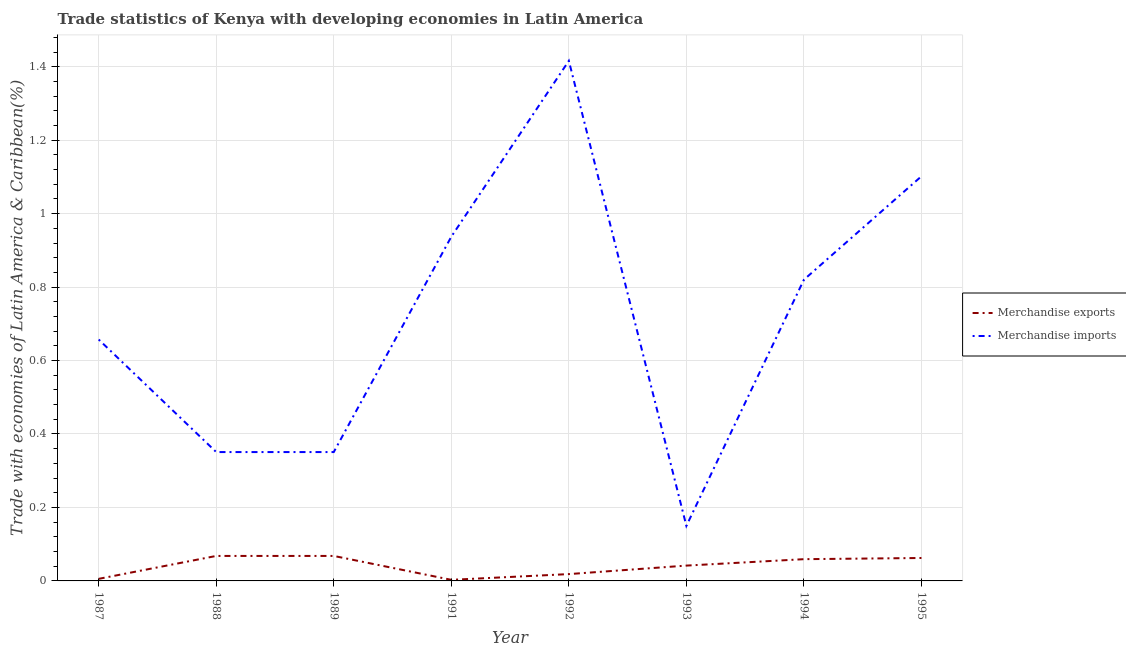How many different coloured lines are there?
Offer a very short reply. 2. Does the line corresponding to merchandise imports intersect with the line corresponding to merchandise exports?
Keep it short and to the point. No. Is the number of lines equal to the number of legend labels?
Provide a short and direct response. Yes. What is the merchandise imports in 1987?
Provide a succinct answer. 0.66. Across all years, what is the maximum merchandise exports?
Ensure brevity in your answer.  0.07. Across all years, what is the minimum merchandise imports?
Give a very brief answer. 0.15. In which year was the merchandise exports minimum?
Ensure brevity in your answer.  1991. What is the total merchandise exports in the graph?
Offer a terse response. 0.33. What is the difference between the merchandise imports in 1991 and that in 1992?
Your answer should be compact. -0.48. What is the difference between the merchandise exports in 1989 and the merchandise imports in 1995?
Your response must be concise. -1.03. What is the average merchandise imports per year?
Your answer should be compact. 0.72. In the year 1994, what is the difference between the merchandise imports and merchandise exports?
Your answer should be compact. 0.76. What is the ratio of the merchandise imports in 1987 to that in 1995?
Provide a short and direct response. 0.6. Is the merchandise exports in 1992 less than that in 1994?
Provide a short and direct response. Yes. What is the difference between the highest and the second highest merchandise imports?
Ensure brevity in your answer.  0.31. What is the difference between the highest and the lowest merchandise imports?
Provide a succinct answer. 1.27. What is the difference between two consecutive major ticks on the Y-axis?
Offer a terse response. 0.2. How are the legend labels stacked?
Provide a succinct answer. Vertical. What is the title of the graph?
Give a very brief answer. Trade statistics of Kenya with developing economies in Latin America. Does "Primary school" appear as one of the legend labels in the graph?
Offer a very short reply. No. What is the label or title of the X-axis?
Offer a very short reply. Year. What is the label or title of the Y-axis?
Your answer should be very brief. Trade with economies of Latin America & Caribbean(%). What is the Trade with economies of Latin America & Caribbean(%) in Merchandise exports in 1987?
Your answer should be compact. 0.01. What is the Trade with economies of Latin America & Caribbean(%) of Merchandise imports in 1987?
Keep it short and to the point. 0.66. What is the Trade with economies of Latin America & Caribbean(%) in Merchandise exports in 1988?
Offer a terse response. 0.07. What is the Trade with economies of Latin America & Caribbean(%) of Merchandise imports in 1988?
Keep it short and to the point. 0.35. What is the Trade with economies of Latin America & Caribbean(%) of Merchandise exports in 1989?
Provide a short and direct response. 0.07. What is the Trade with economies of Latin America & Caribbean(%) of Merchandise imports in 1989?
Provide a short and direct response. 0.35. What is the Trade with economies of Latin America & Caribbean(%) in Merchandise exports in 1991?
Offer a terse response. 0. What is the Trade with economies of Latin America & Caribbean(%) in Merchandise imports in 1991?
Your response must be concise. 0.94. What is the Trade with economies of Latin America & Caribbean(%) in Merchandise exports in 1992?
Offer a very short reply. 0.02. What is the Trade with economies of Latin America & Caribbean(%) in Merchandise imports in 1992?
Offer a very short reply. 1.42. What is the Trade with economies of Latin America & Caribbean(%) of Merchandise exports in 1993?
Your answer should be very brief. 0.04. What is the Trade with economies of Latin America & Caribbean(%) of Merchandise imports in 1993?
Provide a short and direct response. 0.15. What is the Trade with economies of Latin America & Caribbean(%) of Merchandise exports in 1994?
Make the answer very short. 0.06. What is the Trade with economies of Latin America & Caribbean(%) in Merchandise imports in 1994?
Offer a terse response. 0.82. What is the Trade with economies of Latin America & Caribbean(%) of Merchandise exports in 1995?
Keep it short and to the point. 0.06. What is the Trade with economies of Latin America & Caribbean(%) in Merchandise imports in 1995?
Provide a succinct answer. 1.1. Across all years, what is the maximum Trade with economies of Latin America & Caribbean(%) in Merchandise exports?
Offer a terse response. 0.07. Across all years, what is the maximum Trade with economies of Latin America & Caribbean(%) in Merchandise imports?
Your answer should be very brief. 1.42. Across all years, what is the minimum Trade with economies of Latin America & Caribbean(%) of Merchandise exports?
Your answer should be very brief. 0. Across all years, what is the minimum Trade with economies of Latin America & Caribbean(%) in Merchandise imports?
Ensure brevity in your answer.  0.15. What is the total Trade with economies of Latin America & Caribbean(%) of Merchandise exports in the graph?
Provide a short and direct response. 0.33. What is the total Trade with economies of Latin America & Caribbean(%) of Merchandise imports in the graph?
Offer a terse response. 5.78. What is the difference between the Trade with economies of Latin America & Caribbean(%) of Merchandise exports in 1987 and that in 1988?
Your response must be concise. -0.06. What is the difference between the Trade with economies of Latin America & Caribbean(%) of Merchandise imports in 1987 and that in 1988?
Make the answer very short. 0.31. What is the difference between the Trade with economies of Latin America & Caribbean(%) in Merchandise exports in 1987 and that in 1989?
Offer a very short reply. -0.06. What is the difference between the Trade with economies of Latin America & Caribbean(%) in Merchandise imports in 1987 and that in 1989?
Ensure brevity in your answer.  0.31. What is the difference between the Trade with economies of Latin America & Caribbean(%) in Merchandise exports in 1987 and that in 1991?
Ensure brevity in your answer.  0. What is the difference between the Trade with economies of Latin America & Caribbean(%) of Merchandise imports in 1987 and that in 1991?
Offer a terse response. -0.28. What is the difference between the Trade with economies of Latin America & Caribbean(%) in Merchandise exports in 1987 and that in 1992?
Provide a short and direct response. -0.01. What is the difference between the Trade with economies of Latin America & Caribbean(%) in Merchandise imports in 1987 and that in 1992?
Offer a very short reply. -0.76. What is the difference between the Trade with economies of Latin America & Caribbean(%) of Merchandise exports in 1987 and that in 1993?
Your answer should be compact. -0.04. What is the difference between the Trade with economies of Latin America & Caribbean(%) of Merchandise imports in 1987 and that in 1993?
Offer a very short reply. 0.51. What is the difference between the Trade with economies of Latin America & Caribbean(%) in Merchandise exports in 1987 and that in 1994?
Offer a very short reply. -0.05. What is the difference between the Trade with economies of Latin America & Caribbean(%) of Merchandise imports in 1987 and that in 1994?
Provide a short and direct response. -0.16. What is the difference between the Trade with economies of Latin America & Caribbean(%) in Merchandise exports in 1987 and that in 1995?
Give a very brief answer. -0.06. What is the difference between the Trade with economies of Latin America & Caribbean(%) in Merchandise imports in 1987 and that in 1995?
Keep it short and to the point. -0.44. What is the difference between the Trade with economies of Latin America & Caribbean(%) of Merchandise imports in 1988 and that in 1989?
Your response must be concise. -0. What is the difference between the Trade with economies of Latin America & Caribbean(%) in Merchandise exports in 1988 and that in 1991?
Provide a short and direct response. 0.07. What is the difference between the Trade with economies of Latin America & Caribbean(%) in Merchandise imports in 1988 and that in 1991?
Offer a very short reply. -0.59. What is the difference between the Trade with economies of Latin America & Caribbean(%) of Merchandise exports in 1988 and that in 1992?
Give a very brief answer. 0.05. What is the difference between the Trade with economies of Latin America & Caribbean(%) of Merchandise imports in 1988 and that in 1992?
Your answer should be compact. -1.07. What is the difference between the Trade with economies of Latin America & Caribbean(%) of Merchandise exports in 1988 and that in 1993?
Give a very brief answer. 0.03. What is the difference between the Trade with economies of Latin America & Caribbean(%) in Merchandise imports in 1988 and that in 1993?
Offer a very short reply. 0.2. What is the difference between the Trade with economies of Latin America & Caribbean(%) of Merchandise exports in 1988 and that in 1994?
Provide a short and direct response. 0.01. What is the difference between the Trade with economies of Latin America & Caribbean(%) of Merchandise imports in 1988 and that in 1994?
Make the answer very short. -0.47. What is the difference between the Trade with economies of Latin America & Caribbean(%) of Merchandise exports in 1988 and that in 1995?
Give a very brief answer. 0.01. What is the difference between the Trade with economies of Latin America & Caribbean(%) in Merchandise imports in 1988 and that in 1995?
Make the answer very short. -0.75. What is the difference between the Trade with economies of Latin America & Caribbean(%) of Merchandise exports in 1989 and that in 1991?
Give a very brief answer. 0.07. What is the difference between the Trade with economies of Latin America & Caribbean(%) in Merchandise imports in 1989 and that in 1991?
Offer a very short reply. -0.59. What is the difference between the Trade with economies of Latin America & Caribbean(%) in Merchandise exports in 1989 and that in 1992?
Offer a terse response. 0.05. What is the difference between the Trade with economies of Latin America & Caribbean(%) of Merchandise imports in 1989 and that in 1992?
Provide a short and direct response. -1.07. What is the difference between the Trade with economies of Latin America & Caribbean(%) in Merchandise exports in 1989 and that in 1993?
Your answer should be compact. 0.03. What is the difference between the Trade with economies of Latin America & Caribbean(%) in Merchandise imports in 1989 and that in 1993?
Give a very brief answer. 0.2. What is the difference between the Trade with economies of Latin America & Caribbean(%) in Merchandise exports in 1989 and that in 1994?
Keep it short and to the point. 0.01. What is the difference between the Trade with economies of Latin America & Caribbean(%) of Merchandise imports in 1989 and that in 1994?
Your answer should be very brief. -0.47. What is the difference between the Trade with economies of Latin America & Caribbean(%) of Merchandise exports in 1989 and that in 1995?
Your answer should be very brief. 0.01. What is the difference between the Trade with economies of Latin America & Caribbean(%) in Merchandise imports in 1989 and that in 1995?
Provide a succinct answer. -0.75. What is the difference between the Trade with economies of Latin America & Caribbean(%) in Merchandise exports in 1991 and that in 1992?
Offer a very short reply. -0.02. What is the difference between the Trade with economies of Latin America & Caribbean(%) of Merchandise imports in 1991 and that in 1992?
Your answer should be compact. -0.48. What is the difference between the Trade with economies of Latin America & Caribbean(%) of Merchandise exports in 1991 and that in 1993?
Offer a terse response. -0.04. What is the difference between the Trade with economies of Latin America & Caribbean(%) in Merchandise imports in 1991 and that in 1993?
Your response must be concise. 0.79. What is the difference between the Trade with economies of Latin America & Caribbean(%) in Merchandise exports in 1991 and that in 1994?
Your answer should be compact. -0.06. What is the difference between the Trade with economies of Latin America & Caribbean(%) of Merchandise imports in 1991 and that in 1994?
Provide a succinct answer. 0.12. What is the difference between the Trade with economies of Latin America & Caribbean(%) of Merchandise exports in 1991 and that in 1995?
Your response must be concise. -0.06. What is the difference between the Trade with economies of Latin America & Caribbean(%) in Merchandise imports in 1991 and that in 1995?
Your response must be concise. -0.16. What is the difference between the Trade with economies of Latin America & Caribbean(%) of Merchandise exports in 1992 and that in 1993?
Ensure brevity in your answer.  -0.02. What is the difference between the Trade with economies of Latin America & Caribbean(%) of Merchandise imports in 1992 and that in 1993?
Your answer should be compact. 1.27. What is the difference between the Trade with economies of Latin America & Caribbean(%) of Merchandise exports in 1992 and that in 1994?
Provide a short and direct response. -0.04. What is the difference between the Trade with economies of Latin America & Caribbean(%) in Merchandise imports in 1992 and that in 1994?
Ensure brevity in your answer.  0.6. What is the difference between the Trade with economies of Latin America & Caribbean(%) of Merchandise exports in 1992 and that in 1995?
Your response must be concise. -0.04. What is the difference between the Trade with economies of Latin America & Caribbean(%) in Merchandise imports in 1992 and that in 1995?
Provide a short and direct response. 0.31. What is the difference between the Trade with economies of Latin America & Caribbean(%) of Merchandise exports in 1993 and that in 1994?
Ensure brevity in your answer.  -0.02. What is the difference between the Trade with economies of Latin America & Caribbean(%) of Merchandise imports in 1993 and that in 1994?
Provide a succinct answer. -0.67. What is the difference between the Trade with economies of Latin America & Caribbean(%) of Merchandise exports in 1993 and that in 1995?
Your answer should be compact. -0.02. What is the difference between the Trade with economies of Latin America & Caribbean(%) of Merchandise imports in 1993 and that in 1995?
Provide a short and direct response. -0.95. What is the difference between the Trade with economies of Latin America & Caribbean(%) in Merchandise exports in 1994 and that in 1995?
Give a very brief answer. -0. What is the difference between the Trade with economies of Latin America & Caribbean(%) in Merchandise imports in 1994 and that in 1995?
Provide a succinct answer. -0.28. What is the difference between the Trade with economies of Latin America & Caribbean(%) of Merchandise exports in 1987 and the Trade with economies of Latin America & Caribbean(%) of Merchandise imports in 1988?
Make the answer very short. -0.35. What is the difference between the Trade with economies of Latin America & Caribbean(%) of Merchandise exports in 1987 and the Trade with economies of Latin America & Caribbean(%) of Merchandise imports in 1989?
Make the answer very short. -0.35. What is the difference between the Trade with economies of Latin America & Caribbean(%) of Merchandise exports in 1987 and the Trade with economies of Latin America & Caribbean(%) of Merchandise imports in 1991?
Make the answer very short. -0.93. What is the difference between the Trade with economies of Latin America & Caribbean(%) of Merchandise exports in 1987 and the Trade with economies of Latin America & Caribbean(%) of Merchandise imports in 1992?
Your answer should be compact. -1.41. What is the difference between the Trade with economies of Latin America & Caribbean(%) of Merchandise exports in 1987 and the Trade with economies of Latin America & Caribbean(%) of Merchandise imports in 1993?
Provide a short and direct response. -0.14. What is the difference between the Trade with economies of Latin America & Caribbean(%) in Merchandise exports in 1987 and the Trade with economies of Latin America & Caribbean(%) in Merchandise imports in 1994?
Offer a very short reply. -0.81. What is the difference between the Trade with economies of Latin America & Caribbean(%) in Merchandise exports in 1987 and the Trade with economies of Latin America & Caribbean(%) in Merchandise imports in 1995?
Your response must be concise. -1.1. What is the difference between the Trade with economies of Latin America & Caribbean(%) in Merchandise exports in 1988 and the Trade with economies of Latin America & Caribbean(%) in Merchandise imports in 1989?
Your answer should be very brief. -0.28. What is the difference between the Trade with economies of Latin America & Caribbean(%) of Merchandise exports in 1988 and the Trade with economies of Latin America & Caribbean(%) of Merchandise imports in 1991?
Provide a succinct answer. -0.87. What is the difference between the Trade with economies of Latin America & Caribbean(%) of Merchandise exports in 1988 and the Trade with economies of Latin America & Caribbean(%) of Merchandise imports in 1992?
Make the answer very short. -1.35. What is the difference between the Trade with economies of Latin America & Caribbean(%) in Merchandise exports in 1988 and the Trade with economies of Latin America & Caribbean(%) in Merchandise imports in 1993?
Provide a short and direct response. -0.08. What is the difference between the Trade with economies of Latin America & Caribbean(%) of Merchandise exports in 1988 and the Trade with economies of Latin America & Caribbean(%) of Merchandise imports in 1994?
Keep it short and to the point. -0.75. What is the difference between the Trade with economies of Latin America & Caribbean(%) in Merchandise exports in 1988 and the Trade with economies of Latin America & Caribbean(%) in Merchandise imports in 1995?
Offer a very short reply. -1.03. What is the difference between the Trade with economies of Latin America & Caribbean(%) of Merchandise exports in 1989 and the Trade with economies of Latin America & Caribbean(%) of Merchandise imports in 1991?
Keep it short and to the point. -0.87. What is the difference between the Trade with economies of Latin America & Caribbean(%) of Merchandise exports in 1989 and the Trade with economies of Latin America & Caribbean(%) of Merchandise imports in 1992?
Provide a short and direct response. -1.35. What is the difference between the Trade with economies of Latin America & Caribbean(%) of Merchandise exports in 1989 and the Trade with economies of Latin America & Caribbean(%) of Merchandise imports in 1993?
Offer a terse response. -0.08. What is the difference between the Trade with economies of Latin America & Caribbean(%) in Merchandise exports in 1989 and the Trade with economies of Latin America & Caribbean(%) in Merchandise imports in 1994?
Your response must be concise. -0.75. What is the difference between the Trade with economies of Latin America & Caribbean(%) of Merchandise exports in 1989 and the Trade with economies of Latin America & Caribbean(%) of Merchandise imports in 1995?
Your response must be concise. -1.03. What is the difference between the Trade with economies of Latin America & Caribbean(%) in Merchandise exports in 1991 and the Trade with economies of Latin America & Caribbean(%) in Merchandise imports in 1992?
Your answer should be very brief. -1.41. What is the difference between the Trade with economies of Latin America & Caribbean(%) of Merchandise exports in 1991 and the Trade with economies of Latin America & Caribbean(%) of Merchandise imports in 1993?
Ensure brevity in your answer.  -0.15. What is the difference between the Trade with economies of Latin America & Caribbean(%) of Merchandise exports in 1991 and the Trade with economies of Latin America & Caribbean(%) of Merchandise imports in 1994?
Provide a succinct answer. -0.82. What is the difference between the Trade with economies of Latin America & Caribbean(%) of Merchandise exports in 1991 and the Trade with economies of Latin America & Caribbean(%) of Merchandise imports in 1995?
Provide a short and direct response. -1.1. What is the difference between the Trade with economies of Latin America & Caribbean(%) in Merchandise exports in 1992 and the Trade with economies of Latin America & Caribbean(%) in Merchandise imports in 1993?
Ensure brevity in your answer.  -0.13. What is the difference between the Trade with economies of Latin America & Caribbean(%) of Merchandise exports in 1992 and the Trade with economies of Latin America & Caribbean(%) of Merchandise imports in 1994?
Offer a terse response. -0.8. What is the difference between the Trade with economies of Latin America & Caribbean(%) in Merchandise exports in 1992 and the Trade with economies of Latin America & Caribbean(%) in Merchandise imports in 1995?
Your answer should be compact. -1.08. What is the difference between the Trade with economies of Latin America & Caribbean(%) in Merchandise exports in 1993 and the Trade with economies of Latin America & Caribbean(%) in Merchandise imports in 1994?
Your answer should be very brief. -0.78. What is the difference between the Trade with economies of Latin America & Caribbean(%) in Merchandise exports in 1993 and the Trade with economies of Latin America & Caribbean(%) in Merchandise imports in 1995?
Provide a short and direct response. -1.06. What is the difference between the Trade with economies of Latin America & Caribbean(%) of Merchandise exports in 1994 and the Trade with economies of Latin America & Caribbean(%) of Merchandise imports in 1995?
Provide a succinct answer. -1.04. What is the average Trade with economies of Latin America & Caribbean(%) of Merchandise exports per year?
Give a very brief answer. 0.04. What is the average Trade with economies of Latin America & Caribbean(%) of Merchandise imports per year?
Make the answer very short. 0.72. In the year 1987, what is the difference between the Trade with economies of Latin America & Caribbean(%) in Merchandise exports and Trade with economies of Latin America & Caribbean(%) in Merchandise imports?
Provide a short and direct response. -0.65. In the year 1988, what is the difference between the Trade with economies of Latin America & Caribbean(%) in Merchandise exports and Trade with economies of Latin America & Caribbean(%) in Merchandise imports?
Keep it short and to the point. -0.28. In the year 1989, what is the difference between the Trade with economies of Latin America & Caribbean(%) of Merchandise exports and Trade with economies of Latin America & Caribbean(%) of Merchandise imports?
Make the answer very short. -0.28. In the year 1991, what is the difference between the Trade with economies of Latin America & Caribbean(%) of Merchandise exports and Trade with economies of Latin America & Caribbean(%) of Merchandise imports?
Keep it short and to the point. -0.93. In the year 1992, what is the difference between the Trade with economies of Latin America & Caribbean(%) in Merchandise exports and Trade with economies of Latin America & Caribbean(%) in Merchandise imports?
Offer a terse response. -1.4. In the year 1993, what is the difference between the Trade with economies of Latin America & Caribbean(%) in Merchandise exports and Trade with economies of Latin America & Caribbean(%) in Merchandise imports?
Offer a very short reply. -0.11. In the year 1994, what is the difference between the Trade with economies of Latin America & Caribbean(%) of Merchandise exports and Trade with economies of Latin America & Caribbean(%) of Merchandise imports?
Offer a terse response. -0.76. In the year 1995, what is the difference between the Trade with economies of Latin America & Caribbean(%) of Merchandise exports and Trade with economies of Latin America & Caribbean(%) of Merchandise imports?
Provide a succinct answer. -1.04. What is the ratio of the Trade with economies of Latin America & Caribbean(%) of Merchandise exports in 1987 to that in 1988?
Give a very brief answer. 0.08. What is the ratio of the Trade with economies of Latin America & Caribbean(%) in Merchandise imports in 1987 to that in 1988?
Your answer should be very brief. 1.87. What is the ratio of the Trade with economies of Latin America & Caribbean(%) in Merchandise exports in 1987 to that in 1989?
Keep it short and to the point. 0.08. What is the ratio of the Trade with economies of Latin America & Caribbean(%) in Merchandise imports in 1987 to that in 1989?
Give a very brief answer. 1.87. What is the ratio of the Trade with economies of Latin America & Caribbean(%) of Merchandise exports in 1987 to that in 1991?
Your answer should be compact. 1.91. What is the ratio of the Trade with economies of Latin America & Caribbean(%) in Merchandise imports in 1987 to that in 1991?
Offer a terse response. 0.7. What is the ratio of the Trade with economies of Latin America & Caribbean(%) in Merchandise exports in 1987 to that in 1992?
Your answer should be compact. 0.3. What is the ratio of the Trade with economies of Latin America & Caribbean(%) of Merchandise imports in 1987 to that in 1992?
Offer a terse response. 0.46. What is the ratio of the Trade with economies of Latin America & Caribbean(%) in Merchandise exports in 1987 to that in 1993?
Make the answer very short. 0.14. What is the ratio of the Trade with economies of Latin America & Caribbean(%) in Merchandise imports in 1987 to that in 1993?
Your answer should be very brief. 4.39. What is the ratio of the Trade with economies of Latin America & Caribbean(%) of Merchandise exports in 1987 to that in 1994?
Ensure brevity in your answer.  0.1. What is the ratio of the Trade with economies of Latin America & Caribbean(%) in Merchandise imports in 1987 to that in 1994?
Provide a short and direct response. 0.8. What is the ratio of the Trade with economies of Latin America & Caribbean(%) in Merchandise exports in 1987 to that in 1995?
Provide a succinct answer. 0.09. What is the ratio of the Trade with economies of Latin America & Caribbean(%) in Merchandise imports in 1987 to that in 1995?
Ensure brevity in your answer.  0.6. What is the ratio of the Trade with economies of Latin America & Caribbean(%) in Merchandise imports in 1988 to that in 1989?
Provide a succinct answer. 1. What is the ratio of the Trade with economies of Latin America & Caribbean(%) in Merchandise exports in 1988 to that in 1991?
Your answer should be compact. 22.88. What is the ratio of the Trade with economies of Latin America & Caribbean(%) of Merchandise imports in 1988 to that in 1991?
Your answer should be very brief. 0.37. What is the ratio of the Trade with economies of Latin America & Caribbean(%) of Merchandise exports in 1988 to that in 1992?
Keep it short and to the point. 3.66. What is the ratio of the Trade with economies of Latin America & Caribbean(%) in Merchandise imports in 1988 to that in 1992?
Give a very brief answer. 0.25. What is the ratio of the Trade with economies of Latin America & Caribbean(%) of Merchandise exports in 1988 to that in 1993?
Provide a succinct answer. 1.63. What is the ratio of the Trade with economies of Latin America & Caribbean(%) in Merchandise imports in 1988 to that in 1993?
Ensure brevity in your answer.  2.34. What is the ratio of the Trade with economies of Latin America & Caribbean(%) in Merchandise exports in 1988 to that in 1994?
Give a very brief answer. 1.15. What is the ratio of the Trade with economies of Latin America & Caribbean(%) in Merchandise imports in 1988 to that in 1994?
Ensure brevity in your answer.  0.43. What is the ratio of the Trade with economies of Latin America & Caribbean(%) of Merchandise exports in 1988 to that in 1995?
Keep it short and to the point. 1.09. What is the ratio of the Trade with economies of Latin America & Caribbean(%) in Merchandise imports in 1988 to that in 1995?
Offer a very short reply. 0.32. What is the ratio of the Trade with economies of Latin America & Caribbean(%) of Merchandise exports in 1989 to that in 1991?
Provide a short and direct response. 22.88. What is the ratio of the Trade with economies of Latin America & Caribbean(%) in Merchandise imports in 1989 to that in 1991?
Provide a short and direct response. 0.37. What is the ratio of the Trade with economies of Latin America & Caribbean(%) of Merchandise exports in 1989 to that in 1992?
Make the answer very short. 3.66. What is the ratio of the Trade with economies of Latin America & Caribbean(%) of Merchandise imports in 1989 to that in 1992?
Make the answer very short. 0.25. What is the ratio of the Trade with economies of Latin America & Caribbean(%) in Merchandise exports in 1989 to that in 1993?
Keep it short and to the point. 1.63. What is the ratio of the Trade with economies of Latin America & Caribbean(%) in Merchandise imports in 1989 to that in 1993?
Your response must be concise. 2.34. What is the ratio of the Trade with economies of Latin America & Caribbean(%) in Merchandise exports in 1989 to that in 1994?
Provide a short and direct response. 1.15. What is the ratio of the Trade with economies of Latin America & Caribbean(%) of Merchandise imports in 1989 to that in 1994?
Ensure brevity in your answer.  0.43. What is the ratio of the Trade with economies of Latin America & Caribbean(%) in Merchandise exports in 1989 to that in 1995?
Offer a very short reply. 1.09. What is the ratio of the Trade with economies of Latin America & Caribbean(%) of Merchandise imports in 1989 to that in 1995?
Keep it short and to the point. 0.32. What is the ratio of the Trade with economies of Latin America & Caribbean(%) of Merchandise exports in 1991 to that in 1992?
Give a very brief answer. 0.16. What is the ratio of the Trade with economies of Latin America & Caribbean(%) in Merchandise imports in 1991 to that in 1992?
Your answer should be very brief. 0.66. What is the ratio of the Trade with economies of Latin America & Caribbean(%) in Merchandise exports in 1991 to that in 1993?
Your response must be concise. 0.07. What is the ratio of the Trade with economies of Latin America & Caribbean(%) of Merchandise imports in 1991 to that in 1993?
Provide a short and direct response. 6.25. What is the ratio of the Trade with economies of Latin America & Caribbean(%) of Merchandise exports in 1991 to that in 1994?
Provide a succinct answer. 0.05. What is the ratio of the Trade with economies of Latin America & Caribbean(%) in Merchandise imports in 1991 to that in 1994?
Offer a terse response. 1.14. What is the ratio of the Trade with economies of Latin America & Caribbean(%) of Merchandise exports in 1991 to that in 1995?
Make the answer very short. 0.05. What is the ratio of the Trade with economies of Latin America & Caribbean(%) in Merchandise imports in 1991 to that in 1995?
Offer a very short reply. 0.85. What is the ratio of the Trade with economies of Latin America & Caribbean(%) of Merchandise exports in 1992 to that in 1993?
Keep it short and to the point. 0.45. What is the ratio of the Trade with economies of Latin America & Caribbean(%) in Merchandise imports in 1992 to that in 1993?
Ensure brevity in your answer.  9.45. What is the ratio of the Trade with economies of Latin America & Caribbean(%) of Merchandise exports in 1992 to that in 1994?
Provide a succinct answer. 0.31. What is the ratio of the Trade with economies of Latin America & Caribbean(%) in Merchandise imports in 1992 to that in 1994?
Your response must be concise. 1.73. What is the ratio of the Trade with economies of Latin America & Caribbean(%) of Merchandise exports in 1992 to that in 1995?
Offer a very short reply. 0.3. What is the ratio of the Trade with economies of Latin America & Caribbean(%) of Merchandise imports in 1992 to that in 1995?
Give a very brief answer. 1.29. What is the ratio of the Trade with economies of Latin America & Caribbean(%) of Merchandise exports in 1993 to that in 1994?
Offer a terse response. 0.7. What is the ratio of the Trade with economies of Latin America & Caribbean(%) in Merchandise imports in 1993 to that in 1994?
Make the answer very short. 0.18. What is the ratio of the Trade with economies of Latin America & Caribbean(%) in Merchandise exports in 1993 to that in 1995?
Offer a terse response. 0.67. What is the ratio of the Trade with economies of Latin America & Caribbean(%) in Merchandise imports in 1993 to that in 1995?
Provide a short and direct response. 0.14. What is the ratio of the Trade with economies of Latin America & Caribbean(%) in Merchandise exports in 1994 to that in 1995?
Ensure brevity in your answer.  0.95. What is the ratio of the Trade with economies of Latin America & Caribbean(%) in Merchandise imports in 1994 to that in 1995?
Ensure brevity in your answer.  0.74. What is the difference between the highest and the second highest Trade with economies of Latin America & Caribbean(%) of Merchandise exports?
Make the answer very short. 0. What is the difference between the highest and the second highest Trade with economies of Latin America & Caribbean(%) in Merchandise imports?
Your answer should be compact. 0.31. What is the difference between the highest and the lowest Trade with economies of Latin America & Caribbean(%) in Merchandise exports?
Keep it short and to the point. 0.07. What is the difference between the highest and the lowest Trade with economies of Latin America & Caribbean(%) in Merchandise imports?
Your response must be concise. 1.27. 